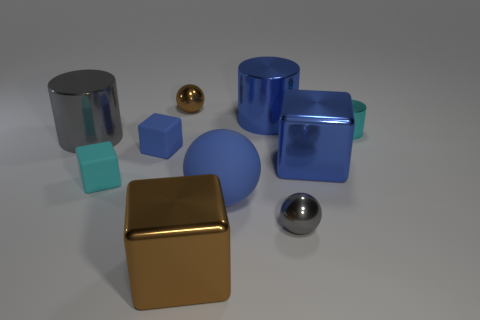Subtract all spheres. How many objects are left? 7 Add 4 cyan things. How many cyan things exist? 6 Subtract 1 brown spheres. How many objects are left? 9 Subtract all large blue things. Subtract all small objects. How many objects are left? 2 Add 5 cyan rubber objects. How many cyan rubber objects are left? 6 